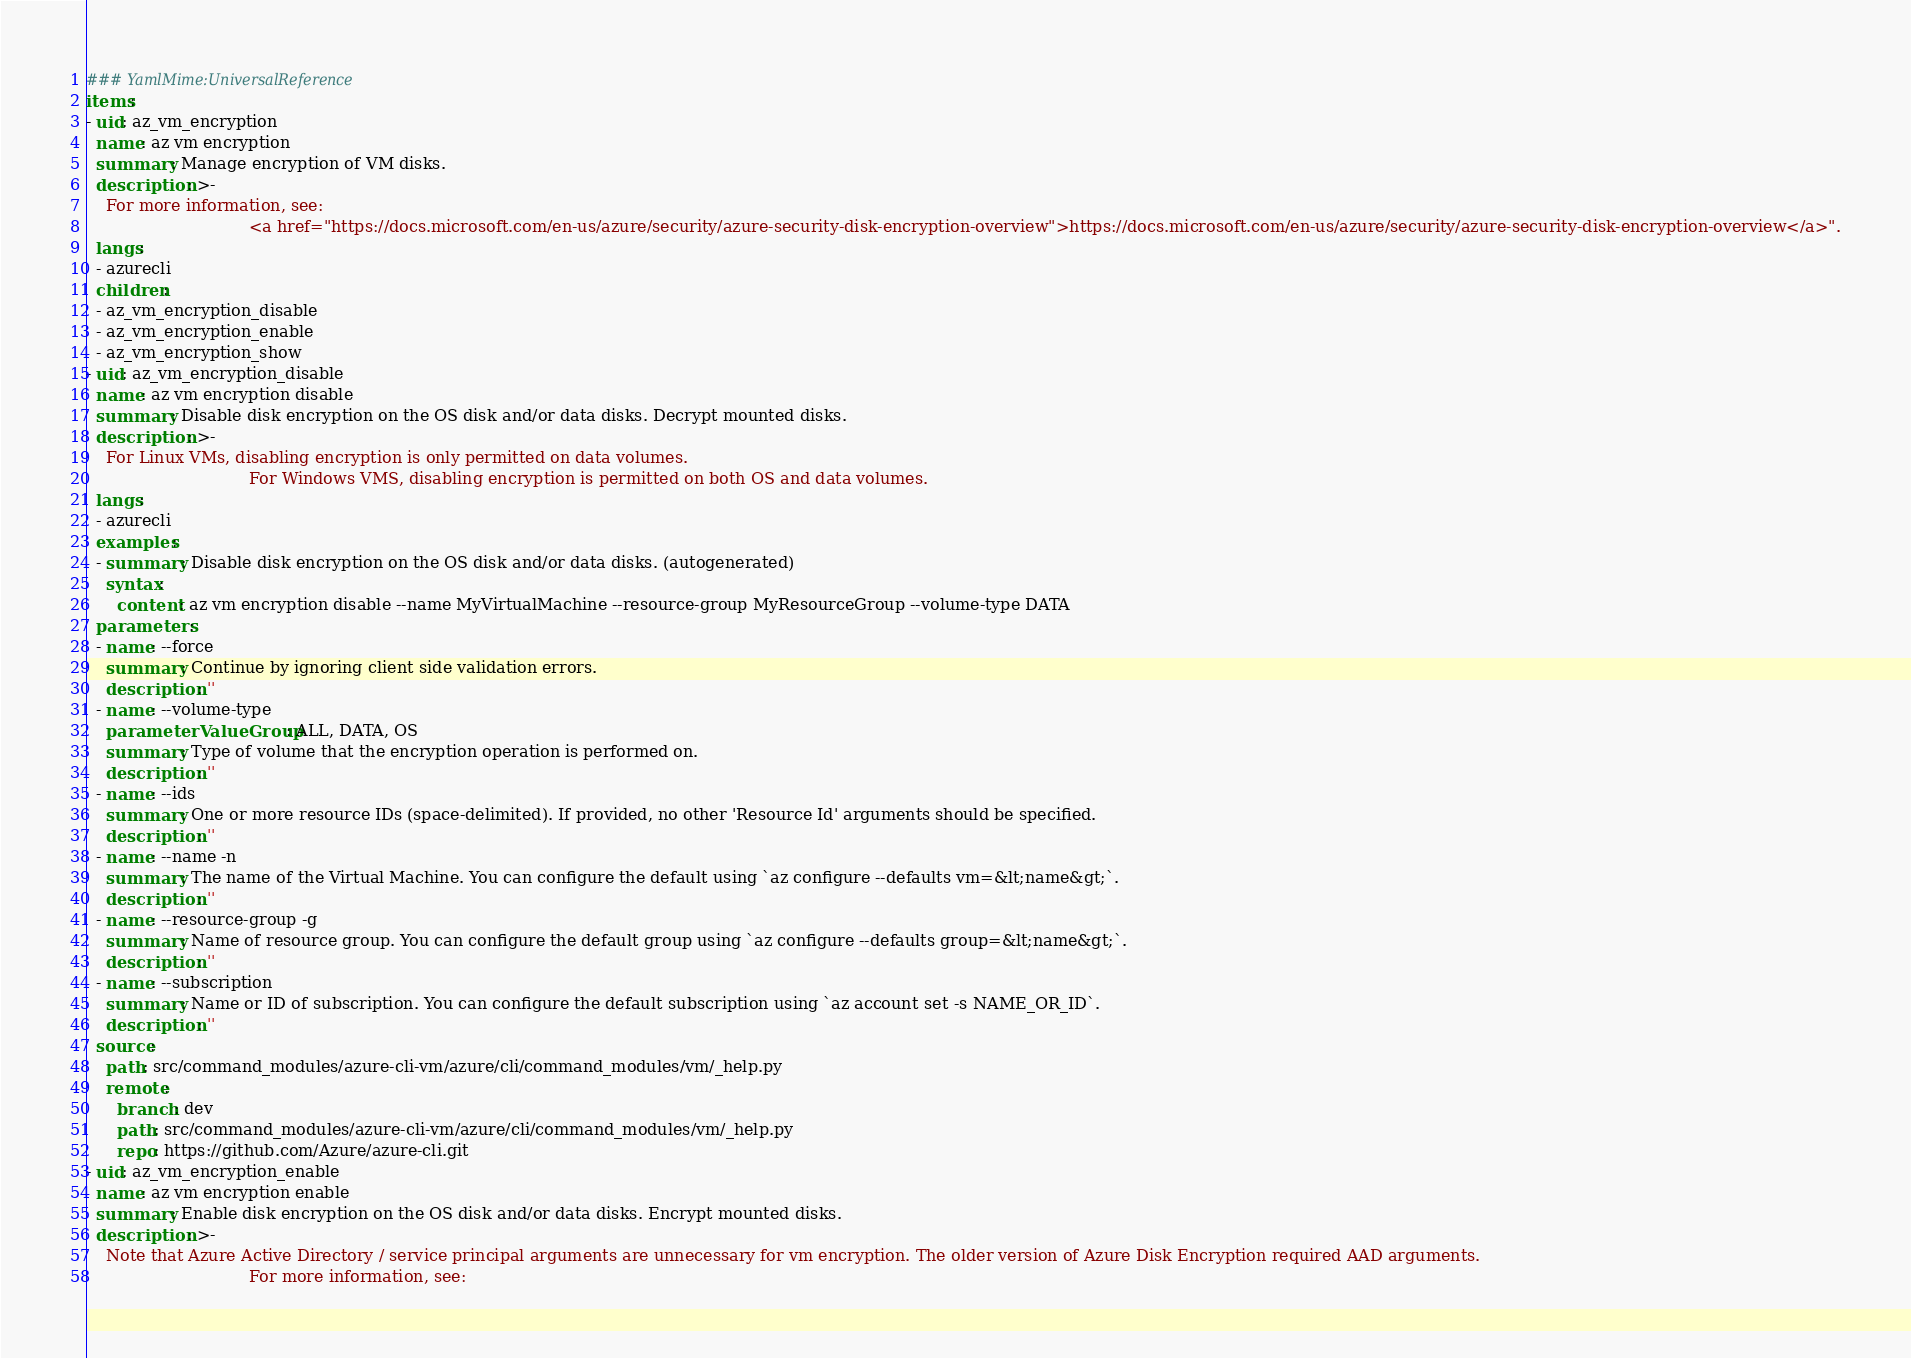Convert code to text. <code><loc_0><loc_0><loc_500><loc_500><_YAML_>### YamlMime:UniversalReference
items:
- uid: az_vm_encryption
  name: az vm encryption
  summary: Manage encryption of VM disks.
  description: >-
    For more information, see:
                                <a href="https://docs.microsoft.com/en-us/azure/security/azure-security-disk-encryption-overview">https://docs.microsoft.com/en-us/azure/security/azure-security-disk-encryption-overview</a>".
  langs:
  - azurecli
  children:
  - az_vm_encryption_disable
  - az_vm_encryption_enable
  - az_vm_encryption_show
- uid: az_vm_encryption_disable
  name: az vm encryption disable
  summary: Disable disk encryption on the OS disk and/or data disks. Decrypt mounted disks.
  description: >-
    For Linux VMs, disabling encryption is only permitted on data volumes.
                                For Windows VMS, disabling encryption is permitted on both OS and data volumes.
  langs:
  - azurecli
  examples:
  - summary: Disable disk encryption on the OS disk and/or data disks. (autogenerated)
    syntax:
      content: az vm encryption disable --name MyVirtualMachine --resource-group MyResourceGroup --volume-type DATA
  parameters:
  - name: --force
    summary: Continue by ignoring client side validation errors.
    description: ''
  - name: --volume-type
    parameterValueGroup: ALL, DATA, OS
    summary: Type of volume that the encryption operation is performed on.
    description: ''
  - name: --ids
    summary: One or more resource IDs (space-delimited). If provided, no other 'Resource Id' arguments should be specified.
    description: ''
  - name: --name -n
    summary: The name of the Virtual Machine. You can configure the default using `az configure --defaults vm=&lt;name&gt;`.
    description: ''
  - name: --resource-group -g
    summary: Name of resource group. You can configure the default group using `az configure --defaults group=&lt;name&gt;`.
    description: ''
  - name: --subscription
    summary: Name or ID of subscription. You can configure the default subscription using `az account set -s NAME_OR_ID`.
    description: ''
  source:
    path: src/command_modules/azure-cli-vm/azure/cli/command_modules/vm/_help.py
    remote:
      branch: dev
      path: src/command_modules/azure-cli-vm/azure/cli/command_modules/vm/_help.py
      repo: https://github.com/Azure/azure-cli.git
- uid: az_vm_encryption_enable
  name: az vm encryption enable
  summary: Enable disk encryption on the OS disk and/or data disks. Encrypt mounted disks.
  description: >-
    Note that Azure Active Directory / service principal arguments are unnecessary for vm encryption. The older version of Azure Disk Encryption required AAD arguments.
                                For more information, see:</code> 